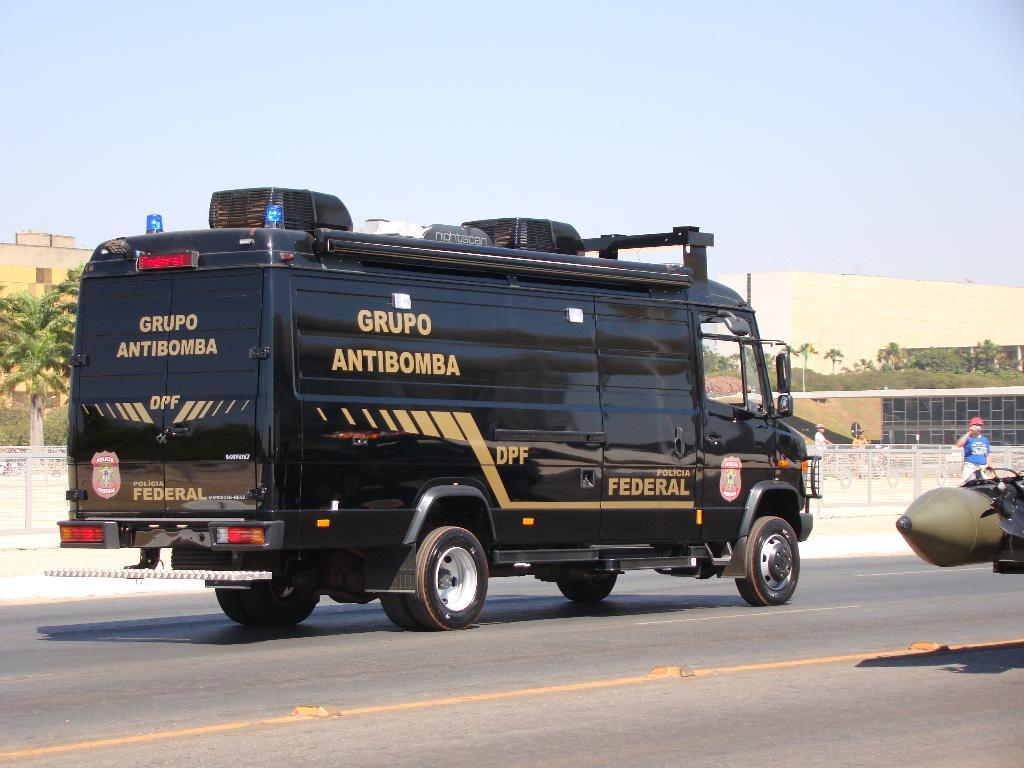<image>
Share a concise interpretation of the image provided. the word Grupo is on the side of the van 